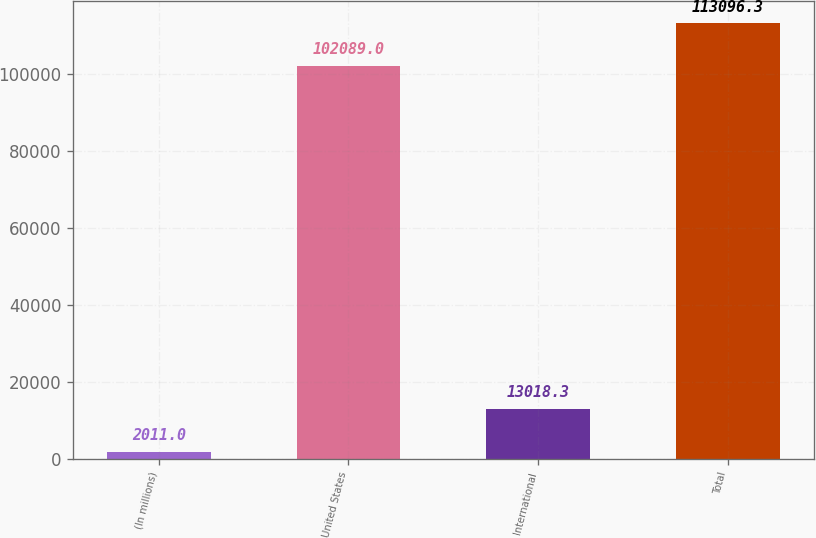<chart> <loc_0><loc_0><loc_500><loc_500><bar_chart><fcel>(In millions)<fcel>United States<fcel>International<fcel>Total<nl><fcel>2011<fcel>102089<fcel>13018.3<fcel>113096<nl></chart> 